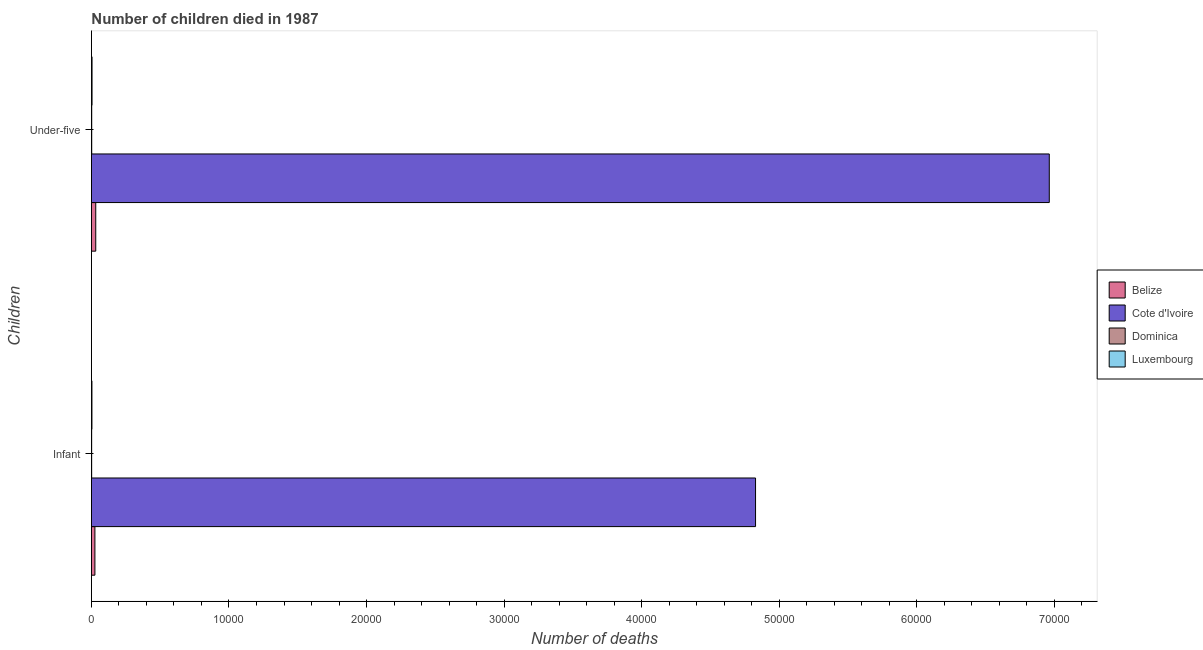How many different coloured bars are there?
Your answer should be compact. 4. How many groups of bars are there?
Your answer should be very brief. 2. Are the number of bars per tick equal to the number of legend labels?
Offer a terse response. Yes. Are the number of bars on each tick of the Y-axis equal?
Provide a short and direct response. Yes. What is the label of the 2nd group of bars from the top?
Ensure brevity in your answer.  Infant. What is the number of under-five deaths in Luxembourg?
Make the answer very short. 45. Across all countries, what is the maximum number of under-five deaths?
Your answer should be compact. 6.96e+04. Across all countries, what is the minimum number of under-five deaths?
Provide a succinct answer. 21. In which country was the number of under-five deaths maximum?
Provide a succinct answer. Cote d'Ivoire. In which country was the number of under-five deaths minimum?
Give a very brief answer. Dominica. What is the total number of infant deaths in the graph?
Your answer should be compact. 4.86e+04. What is the difference between the number of infant deaths in Dominica and that in Luxembourg?
Your answer should be compact. -20. What is the difference between the number of under-five deaths in Belize and the number of infant deaths in Luxembourg?
Provide a short and direct response. 277. What is the average number of under-five deaths per country?
Ensure brevity in your answer.  1.75e+04. What is the difference between the number of under-five deaths and number of infant deaths in Luxembourg?
Ensure brevity in your answer.  8. What is the ratio of the number of under-five deaths in Luxembourg to that in Dominica?
Offer a very short reply. 2.14. Is the number of under-five deaths in Luxembourg less than that in Cote d'Ivoire?
Your response must be concise. Yes. What does the 3rd bar from the top in Under-five represents?
Ensure brevity in your answer.  Cote d'Ivoire. What does the 4th bar from the bottom in Under-five represents?
Offer a terse response. Luxembourg. What is the difference between two consecutive major ticks on the X-axis?
Ensure brevity in your answer.  10000. Are the values on the major ticks of X-axis written in scientific E-notation?
Your answer should be compact. No. Does the graph contain grids?
Make the answer very short. No. Where does the legend appear in the graph?
Your answer should be very brief. Center right. What is the title of the graph?
Provide a short and direct response. Number of children died in 1987. What is the label or title of the X-axis?
Offer a very short reply. Number of deaths. What is the label or title of the Y-axis?
Make the answer very short. Children. What is the Number of deaths in Belize in Infant?
Provide a short and direct response. 253. What is the Number of deaths in Cote d'Ivoire in Infant?
Ensure brevity in your answer.  4.83e+04. What is the Number of deaths in Belize in Under-five?
Keep it short and to the point. 314. What is the Number of deaths in Cote d'Ivoire in Under-five?
Ensure brevity in your answer.  6.96e+04. What is the Number of deaths of Dominica in Under-five?
Offer a very short reply. 21. Across all Children, what is the maximum Number of deaths of Belize?
Make the answer very short. 314. Across all Children, what is the maximum Number of deaths in Cote d'Ivoire?
Offer a very short reply. 6.96e+04. Across all Children, what is the maximum Number of deaths in Luxembourg?
Provide a short and direct response. 45. Across all Children, what is the minimum Number of deaths in Belize?
Keep it short and to the point. 253. Across all Children, what is the minimum Number of deaths in Cote d'Ivoire?
Ensure brevity in your answer.  4.83e+04. Across all Children, what is the minimum Number of deaths in Dominica?
Make the answer very short. 17. Across all Children, what is the minimum Number of deaths in Luxembourg?
Provide a succinct answer. 37. What is the total Number of deaths of Belize in the graph?
Your answer should be very brief. 567. What is the total Number of deaths in Cote d'Ivoire in the graph?
Give a very brief answer. 1.18e+05. What is the total Number of deaths in Luxembourg in the graph?
Offer a terse response. 82. What is the difference between the Number of deaths of Belize in Infant and that in Under-five?
Ensure brevity in your answer.  -61. What is the difference between the Number of deaths in Cote d'Ivoire in Infant and that in Under-five?
Give a very brief answer. -2.14e+04. What is the difference between the Number of deaths of Dominica in Infant and that in Under-five?
Offer a terse response. -4. What is the difference between the Number of deaths in Luxembourg in Infant and that in Under-five?
Your response must be concise. -8. What is the difference between the Number of deaths in Belize in Infant and the Number of deaths in Cote d'Ivoire in Under-five?
Provide a short and direct response. -6.94e+04. What is the difference between the Number of deaths in Belize in Infant and the Number of deaths in Dominica in Under-five?
Keep it short and to the point. 232. What is the difference between the Number of deaths of Belize in Infant and the Number of deaths of Luxembourg in Under-five?
Offer a terse response. 208. What is the difference between the Number of deaths of Cote d'Ivoire in Infant and the Number of deaths of Dominica in Under-five?
Keep it short and to the point. 4.83e+04. What is the difference between the Number of deaths of Cote d'Ivoire in Infant and the Number of deaths of Luxembourg in Under-five?
Your response must be concise. 4.82e+04. What is the difference between the Number of deaths of Dominica in Infant and the Number of deaths of Luxembourg in Under-five?
Make the answer very short. -28. What is the average Number of deaths in Belize per Children?
Provide a short and direct response. 283.5. What is the average Number of deaths in Cote d'Ivoire per Children?
Make the answer very short. 5.90e+04. What is the average Number of deaths of Dominica per Children?
Your response must be concise. 19. What is the average Number of deaths in Luxembourg per Children?
Offer a terse response. 41. What is the difference between the Number of deaths of Belize and Number of deaths of Cote d'Ivoire in Infant?
Keep it short and to the point. -4.80e+04. What is the difference between the Number of deaths of Belize and Number of deaths of Dominica in Infant?
Keep it short and to the point. 236. What is the difference between the Number of deaths in Belize and Number of deaths in Luxembourg in Infant?
Ensure brevity in your answer.  216. What is the difference between the Number of deaths in Cote d'Ivoire and Number of deaths in Dominica in Infant?
Ensure brevity in your answer.  4.83e+04. What is the difference between the Number of deaths of Cote d'Ivoire and Number of deaths of Luxembourg in Infant?
Provide a succinct answer. 4.82e+04. What is the difference between the Number of deaths of Belize and Number of deaths of Cote d'Ivoire in Under-five?
Ensure brevity in your answer.  -6.93e+04. What is the difference between the Number of deaths of Belize and Number of deaths of Dominica in Under-five?
Ensure brevity in your answer.  293. What is the difference between the Number of deaths in Belize and Number of deaths in Luxembourg in Under-five?
Your response must be concise. 269. What is the difference between the Number of deaths of Cote d'Ivoire and Number of deaths of Dominica in Under-five?
Offer a terse response. 6.96e+04. What is the difference between the Number of deaths in Cote d'Ivoire and Number of deaths in Luxembourg in Under-five?
Provide a short and direct response. 6.96e+04. What is the ratio of the Number of deaths in Belize in Infant to that in Under-five?
Provide a succinct answer. 0.81. What is the ratio of the Number of deaths of Cote d'Ivoire in Infant to that in Under-five?
Your answer should be compact. 0.69. What is the ratio of the Number of deaths of Dominica in Infant to that in Under-five?
Ensure brevity in your answer.  0.81. What is the ratio of the Number of deaths in Luxembourg in Infant to that in Under-five?
Make the answer very short. 0.82. What is the difference between the highest and the second highest Number of deaths of Belize?
Offer a terse response. 61. What is the difference between the highest and the second highest Number of deaths of Cote d'Ivoire?
Provide a succinct answer. 2.14e+04. What is the difference between the highest and the second highest Number of deaths of Dominica?
Give a very brief answer. 4. What is the difference between the highest and the lowest Number of deaths in Cote d'Ivoire?
Offer a terse response. 2.14e+04. What is the difference between the highest and the lowest Number of deaths in Dominica?
Your response must be concise. 4. 